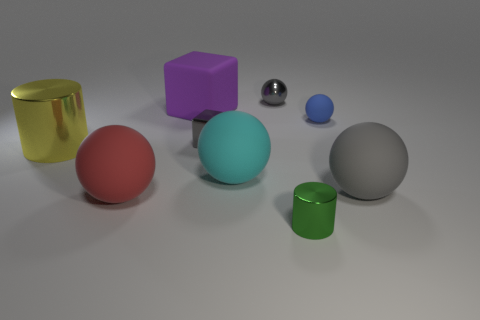Looking at the sizes, can you arrange the objects from largest to smallest? Certainly! From largest to smallest, the objects are: the teal sphere, the red sphere, the grey sphere, the violet cube, the gold cylinder, the green cylinder, the small blue sphere, and finally the tiny silver cube.  Which object appears to be in front of all others? The green cylinder appears to be in front of all other objects, given its placement in the foreground of the image. 